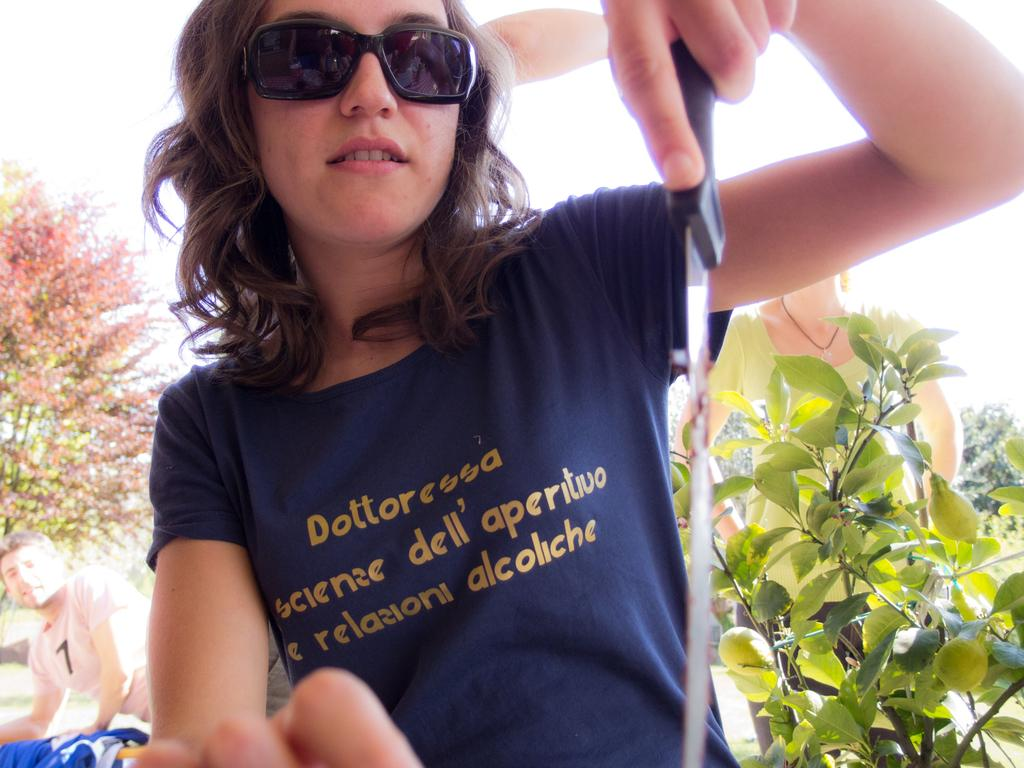Who is the main subject in the image? There is a woman in the image. What is the woman holding in the image? The woman is holding a knife. What can be seen in the background of the image? There are plants and trees behind the woman. Is there anyone else in the image besides the woman? Yes, there is a man to the left of the woman. What is visible at the top of the image? The sky is visible at the top of the image. What type of riddle is the woman trying to solve in the image? There is no indication in the image that the woman is trying to solve a riddle; she is simply holding a knife. 